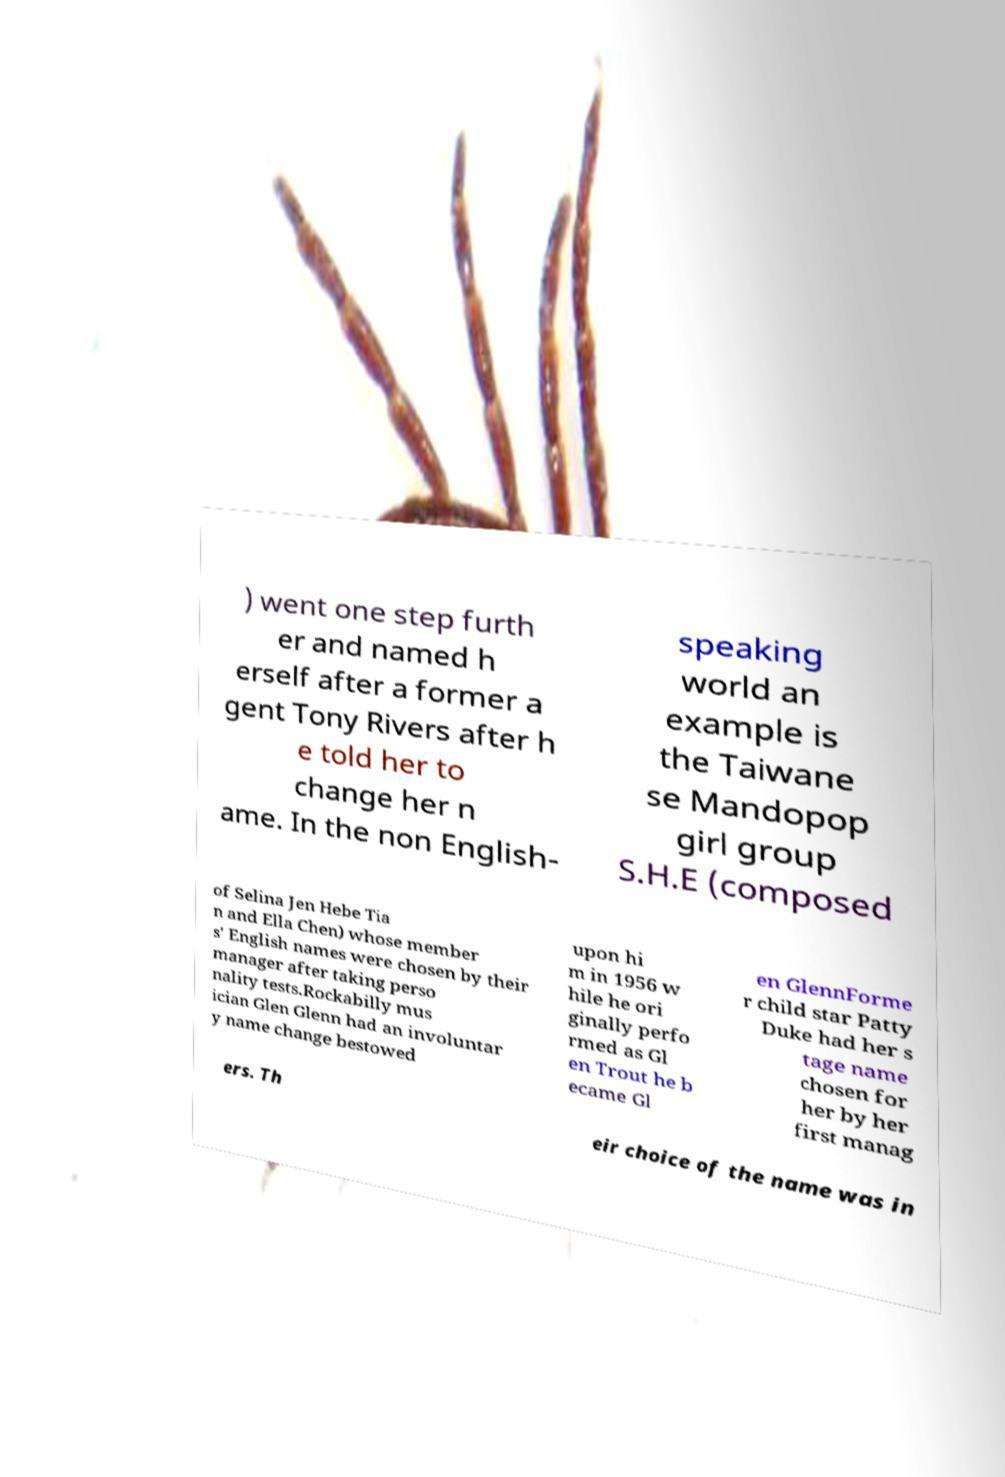Please identify and transcribe the text found in this image. ) went one step furth er and named h erself after a former a gent Tony Rivers after h e told her to change her n ame. In the non English- speaking world an example is the Taiwane se Mandopop girl group S.H.E (composed of Selina Jen Hebe Tia n and Ella Chen) whose member s' English names were chosen by their manager after taking perso nality tests.Rockabilly mus ician Glen Glenn had an involuntar y name change bestowed upon hi m in 1956 w hile he ori ginally perfo rmed as Gl en Trout he b ecame Gl en GlennForme r child star Patty Duke had her s tage name chosen for her by her first manag ers. Th eir choice of the name was in 